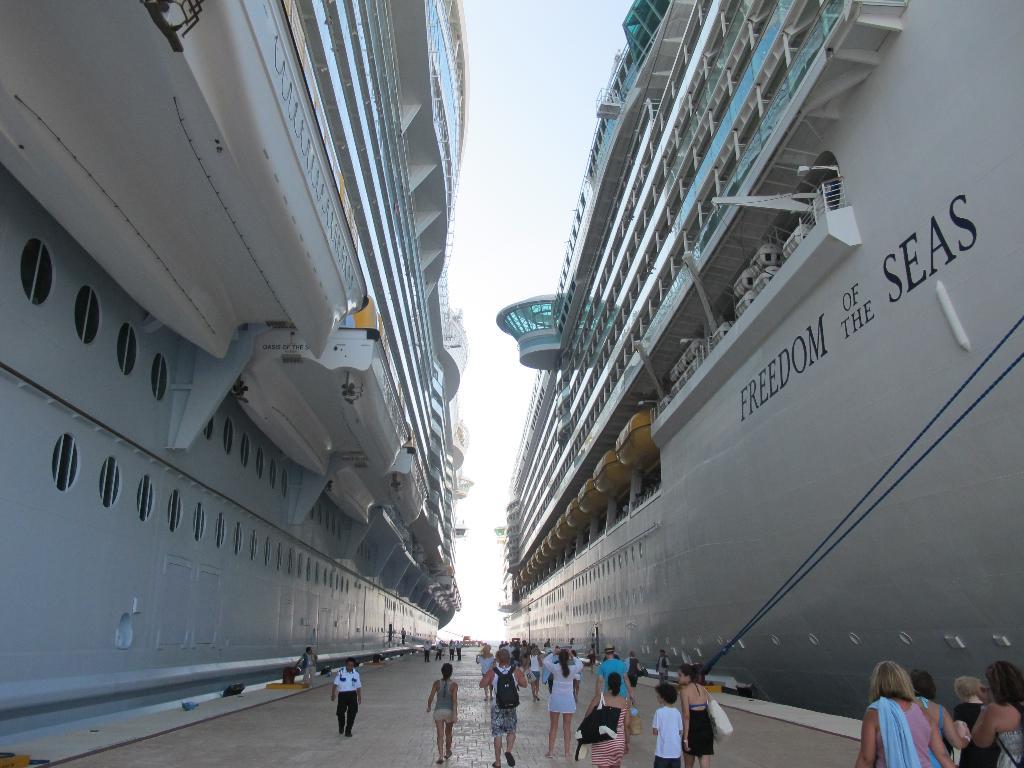What is the name of the cruise ship?
Your answer should be very brief. Freedom of the seas. 